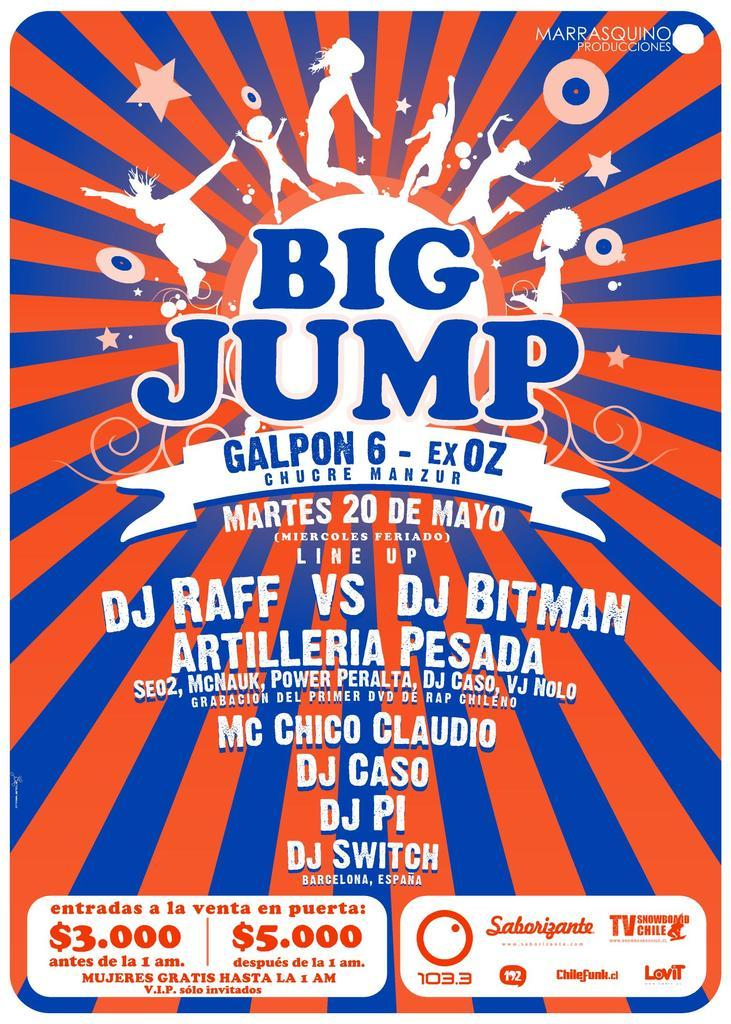<image>
Summarize the visual content of the image. A poster about the Big Jump Galpon 6 - Ex OZ event on Martes 20 De Mayo 